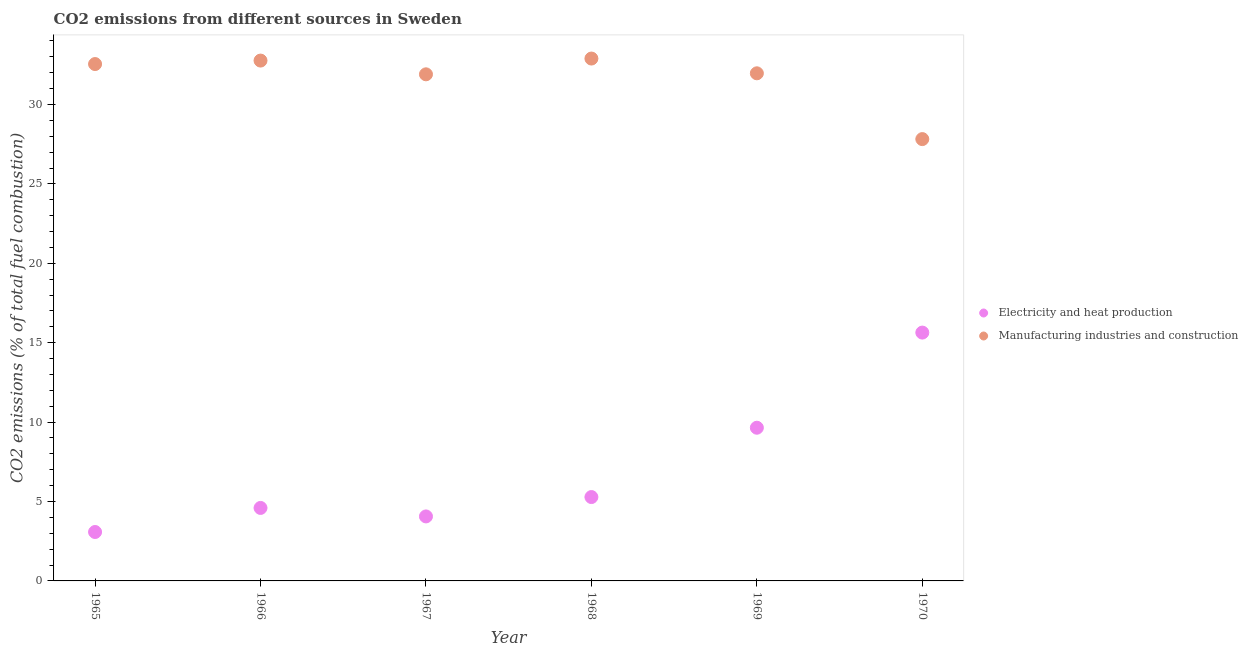Is the number of dotlines equal to the number of legend labels?
Offer a very short reply. Yes. What is the co2 emissions due to electricity and heat production in 1968?
Your answer should be compact. 5.28. Across all years, what is the maximum co2 emissions due to manufacturing industries?
Offer a very short reply. 32.89. Across all years, what is the minimum co2 emissions due to manufacturing industries?
Keep it short and to the point. 27.82. In which year was the co2 emissions due to electricity and heat production maximum?
Your response must be concise. 1970. In which year was the co2 emissions due to electricity and heat production minimum?
Provide a short and direct response. 1965. What is the total co2 emissions due to manufacturing industries in the graph?
Provide a short and direct response. 189.89. What is the difference between the co2 emissions due to manufacturing industries in 1965 and that in 1968?
Your answer should be very brief. -0.35. What is the difference between the co2 emissions due to manufacturing industries in 1967 and the co2 emissions due to electricity and heat production in 1970?
Offer a terse response. 16.26. What is the average co2 emissions due to electricity and heat production per year?
Keep it short and to the point. 7.05. In the year 1967, what is the difference between the co2 emissions due to manufacturing industries and co2 emissions due to electricity and heat production?
Your response must be concise. 27.84. In how many years, is the co2 emissions due to manufacturing industries greater than 22 %?
Keep it short and to the point. 6. What is the ratio of the co2 emissions due to electricity and heat production in 1967 to that in 1968?
Give a very brief answer. 0.77. Is the difference between the co2 emissions due to electricity and heat production in 1965 and 1966 greater than the difference between the co2 emissions due to manufacturing industries in 1965 and 1966?
Your response must be concise. No. What is the difference between the highest and the second highest co2 emissions due to manufacturing industries?
Offer a terse response. 0.13. What is the difference between the highest and the lowest co2 emissions due to manufacturing industries?
Offer a very short reply. 5.07. In how many years, is the co2 emissions due to electricity and heat production greater than the average co2 emissions due to electricity and heat production taken over all years?
Keep it short and to the point. 2. Is the co2 emissions due to electricity and heat production strictly greater than the co2 emissions due to manufacturing industries over the years?
Make the answer very short. No. Is the co2 emissions due to electricity and heat production strictly less than the co2 emissions due to manufacturing industries over the years?
Give a very brief answer. Yes. How many dotlines are there?
Offer a very short reply. 2. How many years are there in the graph?
Give a very brief answer. 6. Does the graph contain grids?
Provide a succinct answer. No. Where does the legend appear in the graph?
Provide a succinct answer. Center right. What is the title of the graph?
Ensure brevity in your answer.  CO2 emissions from different sources in Sweden. Does "Private credit bureau" appear as one of the legend labels in the graph?
Your answer should be compact. No. What is the label or title of the X-axis?
Offer a very short reply. Year. What is the label or title of the Y-axis?
Your answer should be very brief. CO2 emissions (% of total fuel combustion). What is the CO2 emissions (% of total fuel combustion) in Electricity and heat production in 1965?
Ensure brevity in your answer.  3.08. What is the CO2 emissions (% of total fuel combustion) of Manufacturing industries and construction in 1965?
Provide a short and direct response. 32.55. What is the CO2 emissions (% of total fuel combustion) in Electricity and heat production in 1966?
Your response must be concise. 4.6. What is the CO2 emissions (% of total fuel combustion) in Manufacturing industries and construction in 1966?
Offer a terse response. 32.77. What is the CO2 emissions (% of total fuel combustion) in Electricity and heat production in 1967?
Provide a short and direct response. 4.06. What is the CO2 emissions (% of total fuel combustion) of Manufacturing industries and construction in 1967?
Ensure brevity in your answer.  31.9. What is the CO2 emissions (% of total fuel combustion) in Electricity and heat production in 1968?
Make the answer very short. 5.28. What is the CO2 emissions (% of total fuel combustion) of Manufacturing industries and construction in 1968?
Offer a very short reply. 32.89. What is the CO2 emissions (% of total fuel combustion) in Electricity and heat production in 1969?
Give a very brief answer. 9.65. What is the CO2 emissions (% of total fuel combustion) of Manufacturing industries and construction in 1969?
Ensure brevity in your answer.  31.96. What is the CO2 emissions (% of total fuel combustion) in Electricity and heat production in 1970?
Ensure brevity in your answer.  15.64. What is the CO2 emissions (% of total fuel combustion) in Manufacturing industries and construction in 1970?
Your response must be concise. 27.82. Across all years, what is the maximum CO2 emissions (% of total fuel combustion) in Electricity and heat production?
Your answer should be compact. 15.64. Across all years, what is the maximum CO2 emissions (% of total fuel combustion) of Manufacturing industries and construction?
Offer a very short reply. 32.89. Across all years, what is the minimum CO2 emissions (% of total fuel combustion) of Electricity and heat production?
Give a very brief answer. 3.08. Across all years, what is the minimum CO2 emissions (% of total fuel combustion) in Manufacturing industries and construction?
Provide a short and direct response. 27.82. What is the total CO2 emissions (% of total fuel combustion) in Electricity and heat production in the graph?
Provide a succinct answer. 42.3. What is the total CO2 emissions (% of total fuel combustion) of Manufacturing industries and construction in the graph?
Provide a short and direct response. 189.89. What is the difference between the CO2 emissions (% of total fuel combustion) in Electricity and heat production in 1965 and that in 1966?
Provide a short and direct response. -1.52. What is the difference between the CO2 emissions (% of total fuel combustion) of Manufacturing industries and construction in 1965 and that in 1966?
Your response must be concise. -0.22. What is the difference between the CO2 emissions (% of total fuel combustion) in Electricity and heat production in 1965 and that in 1967?
Your response must be concise. -0.98. What is the difference between the CO2 emissions (% of total fuel combustion) of Manufacturing industries and construction in 1965 and that in 1967?
Provide a succinct answer. 0.65. What is the difference between the CO2 emissions (% of total fuel combustion) of Electricity and heat production in 1965 and that in 1968?
Provide a succinct answer. -2.2. What is the difference between the CO2 emissions (% of total fuel combustion) of Manufacturing industries and construction in 1965 and that in 1968?
Keep it short and to the point. -0.35. What is the difference between the CO2 emissions (% of total fuel combustion) in Electricity and heat production in 1965 and that in 1969?
Ensure brevity in your answer.  -6.57. What is the difference between the CO2 emissions (% of total fuel combustion) in Manufacturing industries and construction in 1965 and that in 1969?
Your response must be concise. 0.58. What is the difference between the CO2 emissions (% of total fuel combustion) of Electricity and heat production in 1965 and that in 1970?
Provide a succinct answer. -12.56. What is the difference between the CO2 emissions (% of total fuel combustion) of Manufacturing industries and construction in 1965 and that in 1970?
Offer a terse response. 4.73. What is the difference between the CO2 emissions (% of total fuel combustion) in Electricity and heat production in 1966 and that in 1967?
Your answer should be very brief. 0.53. What is the difference between the CO2 emissions (% of total fuel combustion) of Manufacturing industries and construction in 1966 and that in 1967?
Ensure brevity in your answer.  0.87. What is the difference between the CO2 emissions (% of total fuel combustion) in Electricity and heat production in 1966 and that in 1968?
Ensure brevity in your answer.  -0.69. What is the difference between the CO2 emissions (% of total fuel combustion) of Manufacturing industries and construction in 1966 and that in 1968?
Your response must be concise. -0.13. What is the difference between the CO2 emissions (% of total fuel combustion) of Electricity and heat production in 1966 and that in 1969?
Your answer should be very brief. -5.05. What is the difference between the CO2 emissions (% of total fuel combustion) in Manufacturing industries and construction in 1966 and that in 1969?
Keep it short and to the point. 0.8. What is the difference between the CO2 emissions (% of total fuel combustion) in Electricity and heat production in 1966 and that in 1970?
Provide a succinct answer. -11.04. What is the difference between the CO2 emissions (% of total fuel combustion) of Manufacturing industries and construction in 1966 and that in 1970?
Your response must be concise. 4.94. What is the difference between the CO2 emissions (% of total fuel combustion) in Electricity and heat production in 1967 and that in 1968?
Offer a terse response. -1.22. What is the difference between the CO2 emissions (% of total fuel combustion) of Manufacturing industries and construction in 1967 and that in 1968?
Your answer should be compact. -0.99. What is the difference between the CO2 emissions (% of total fuel combustion) in Electricity and heat production in 1967 and that in 1969?
Offer a terse response. -5.59. What is the difference between the CO2 emissions (% of total fuel combustion) in Manufacturing industries and construction in 1967 and that in 1969?
Your answer should be very brief. -0.06. What is the difference between the CO2 emissions (% of total fuel combustion) in Electricity and heat production in 1967 and that in 1970?
Your answer should be very brief. -11.58. What is the difference between the CO2 emissions (% of total fuel combustion) of Manufacturing industries and construction in 1967 and that in 1970?
Ensure brevity in your answer.  4.08. What is the difference between the CO2 emissions (% of total fuel combustion) in Electricity and heat production in 1968 and that in 1969?
Your response must be concise. -4.37. What is the difference between the CO2 emissions (% of total fuel combustion) in Manufacturing industries and construction in 1968 and that in 1969?
Your answer should be very brief. 0.93. What is the difference between the CO2 emissions (% of total fuel combustion) in Electricity and heat production in 1968 and that in 1970?
Keep it short and to the point. -10.36. What is the difference between the CO2 emissions (% of total fuel combustion) in Manufacturing industries and construction in 1968 and that in 1970?
Make the answer very short. 5.07. What is the difference between the CO2 emissions (% of total fuel combustion) in Electricity and heat production in 1969 and that in 1970?
Provide a short and direct response. -5.99. What is the difference between the CO2 emissions (% of total fuel combustion) in Manufacturing industries and construction in 1969 and that in 1970?
Keep it short and to the point. 4.14. What is the difference between the CO2 emissions (% of total fuel combustion) in Electricity and heat production in 1965 and the CO2 emissions (% of total fuel combustion) in Manufacturing industries and construction in 1966?
Provide a short and direct response. -29.68. What is the difference between the CO2 emissions (% of total fuel combustion) of Electricity and heat production in 1965 and the CO2 emissions (% of total fuel combustion) of Manufacturing industries and construction in 1967?
Keep it short and to the point. -28.82. What is the difference between the CO2 emissions (% of total fuel combustion) of Electricity and heat production in 1965 and the CO2 emissions (% of total fuel combustion) of Manufacturing industries and construction in 1968?
Your answer should be very brief. -29.81. What is the difference between the CO2 emissions (% of total fuel combustion) in Electricity and heat production in 1965 and the CO2 emissions (% of total fuel combustion) in Manufacturing industries and construction in 1969?
Give a very brief answer. -28.88. What is the difference between the CO2 emissions (% of total fuel combustion) of Electricity and heat production in 1965 and the CO2 emissions (% of total fuel combustion) of Manufacturing industries and construction in 1970?
Your response must be concise. -24.74. What is the difference between the CO2 emissions (% of total fuel combustion) of Electricity and heat production in 1966 and the CO2 emissions (% of total fuel combustion) of Manufacturing industries and construction in 1967?
Your answer should be compact. -27.3. What is the difference between the CO2 emissions (% of total fuel combustion) of Electricity and heat production in 1966 and the CO2 emissions (% of total fuel combustion) of Manufacturing industries and construction in 1968?
Ensure brevity in your answer.  -28.3. What is the difference between the CO2 emissions (% of total fuel combustion) of Electricity and heat production in 1966 and the CO2 emissions (% of total fuel combustion) of Manufacturing industries and construction in 1969?
Offer a very short reply. -27.37. What is the difference between the CO2 emissions (% of total fuel combustion) of Electricity and heat production in 1966 and the CO2 emissions (% of total fuel combustion) of Manufacturing industries and construction in 1970?
Your answer should be compact. -23.23. What is the difference between the CO2 emissions (% of total fuel combustion) in Electricity and heat production in 1967 and the CO2 emissions (% of total fuel combustion) in Manufacturing industries and construction in 1968?
Give a very brief answer. -28.83. What is the difference between the CO2 emissions (% of total fuel combustion) of Electricity and heat production in 1967 and the CO2 emissions (% of total fuel combustion) of Manufacturing industries and construction in 1969?
Your response must be concise. -27.9. What is the difference between the CO2 emissions (% of total fuel combustion) in Electricity and heat production in 1967 and the CO2 emissions (% of total fuel combustion) in Manufacturing industries and construction in 1970?
Provide a short and direct response. -23.76. What is the difference between the CO2 emissions (% of total fuel combustion) in Electricity and heat production in 1968 and the CO2 emissions (% of total fuel combustion) in Manufacturing industries and construction in 1969?
Make the answer very short. -26.68. What is the difference between the CO2 emissions (% of total fuel combustion) in Electricity and heat production in 1968 and the CO2 emissions (% of total fuel combustion) in Manufacturing industries and construction in 1970?
Ensure brevity in your answer.  -22.54. What is the difference between the CO2 emissions (% of total fuel combustion) of Electricity and heat production in 1969 and the CO2 emissions (% of total fuel combustion) of Manufacturing industries and construction in 1970?
Provide a succinct answer. -18.17. What is the average CO2 emissions (% of total fuel combustion) in Electricity and heat production per year?
Make the answer very short. 7.05. What is the average CO2 emissions (% of total fuel combustion) in Manufacturing industries and construction per year?
Give a very brief answer. 31.65. In the year 1965, what is the difference between the CO2 emissions (% of total fuel combustion) of Electricity and heat production and CO2 emissions (% of total fuel combustion) of Manufacturing industries and construction?
Ensure brevity in your answer.  -29.47. In the year 1966, what is the difference between the CO2 emissions (% of total fuel combustion) in Electricity and heat production and CO2 emissions (% of total fuel combustion) in Manufacturing industries and construction?
Offer a very short reply. -28.17. In the year 1967, what is the difference between the CO2 emissions (% of total fuel combustion) in Electricity and heat production and CO2 emissions (% of total fuel combustion) in Manufacturing industries and construction?
Give a very brief answer. -27.84. In the year 1968, what is the difference between the CO2 emissions (% of total fuel combustion) of Electricity and heat production and CO2 emissions (% of total fuel combustion) of Manufacturing industries and construction?
Offer a terse response. -27.61. In the year 1969, what is the difference between the CO2 emissions (% of total fuel combustion) in Electricity and heat production and CO2 emissions (% of total fuel combustion) in Manufacturing industries and construction?
Offer a terse response. -22.32. In the year 1970, what is the difference between the CO2 emissions (% of total fuel combustion) of Electricity and heat production and CO2 emissions (% of total fuel combustion) of Manufacturing industries and construction?
Ensure brevity in your answer.  -12.18. What is the ratio of the CO2 emissions (% of total fuel combustion) in Electricity and heat production in 1965 to that in 1966?
Keep it short and to the point. 0.67. What is the ratio of the CO2 emissions (% of total fuel combustion) in Manufacturing industries and construction in 1965 to that in 1966?
Ensure brevity in your answer.  0.99. What is the ratio of the CO2 emissions (% of total fuel combustion) in Electricity and heat production in 1965 to that in 1967?
Make the answer very short. 0.76. What is the ratio of the CO2 emissions (% of total fuel combustion) of Manufacturing industries and construction in 1965 to that in 1967?
Give a very brief answer. 1.02. What is the ratio of the CO2 emissions (% of total fuel combustion) in Electricity and heat production in 1965 to that in 1968?
Your answer should be very brief. 0.58. What is the ratio of the CO2 emissions (% of total fuel combustion) in Manufacturing industries and construction in 1965 to that in 1968?
Make the answer very short. 0.99. What is the ratio of the CO2 emissions (% of total fuel combustion) in Electricity and heat production in 1965 to that in 1969?
Provide a succinct answer. 0.32. What is the ratio of the CO2 emissions (% of total fuel combustion) in Manufacturing industries and construction in 1965 to that in 1969?
Your answer should be very brief. 1.02. What is the ratio of the CO2 emissions (% of total fuel combustion) of Electricity and heat production in 1965 to that in 1970?
Ensure brevity in your answer.  0.2. What is the ratio of the CO2 emissions (% of total fuel combustion) of Manufacturing industries and construction in 1965 to that in 1970?
Keep it short and to the point. 1.17. What is the ratio of the CO2 emissions (% of total fuel combustion) in Electricity and heat production in 1966 to that in 1967?
Offer a very short reply. 1.13. What is the ratio of the CO2 emissions (% of total fuel combustion) in Manufacturing industries and construction in 1966 to that in 1967?
Give a very brief answer. 1.03. What is the ratio of the CO2 emissions (% of total fuel combustion) of Electricity and heat production in 1966 to that in 1968?
Ensure brevity in your answer.  0.87. What is the ratio of the CO2 emissions (% of total fuel combustion) in Manufacturing industries and construction in 1966 to that in 1968?
Your answer should be compact. 1. What is the ratio of the CO2 emissions (% of total fuel combustion) of Electricity and heat production in 1966 to that in 1969?
Your response must be concise. 0.48. What is the ratio of the CO2 emissions (% of total fuel combustion) of Manufacturing industries and construction in 1966 to that in 1969?
Keep it short and to the point. 1.03. What is the ratio of the CO2 emissions (% of total fuel combustion) in Electricity and heat production in 1966 to that in 1970?
Give a very brief answer. 0.29. What is the ratio of the CO2 emissions (% of total fuel combustion) of Manufacturing industries and construction in 1966 to that in 1970?
Your response must be concise. 1.18. What is the ratio of the CO2 emissions (% of total fuel combustion) of Electricity and heat production in 1967 to that in 1968?
Your answer should be compact. 0.77. What is the ratio of the CO2 emissions (% of total fuel combustion) of Manufacturing industries and construction in 1967 to that in 1968?
Ensure brevity in your answer.  0.97. What is the ratio of the CO2 emissions (% of total fuel combustion) of Electricity and heat production in 1967 to that in 1969?
Make the answer very short. 0.42. What is the ratio of the CO2 emissions (% of total fuel combustion) in Electricity and heat production in 1967 to that in 1970?
Your answer should be compact. 0.26. What is the ratio of the CO2 emissions (% of total fuel combustion) of Manufacturing industries and construction in 1967 to that in 1970?
Your answer should be compact. 1.15. What is the ratio of the CO2 emissions (% of total fuel combustion) in Electricity and heat production in 1968 to that in 1969?
Provide a succinct answer. 0.55. What is the ratio of the CO2 emissions (% of total fuel combustion) of Manufacturing industries and construction in 1968 to that in 1969?
Your answer should be compact. 1.03. What is the ratio of the CO2 emissions (% of total fuel combustion) of Electricity and heat production in 1968 to that in 1970?
Keep it short and to the point. 0.34. What is the ratio of the CO2 emissions (% of total fuel combustion) in Manufacturing industries and construction in 1968 to that in 1970?
Your answer should be compact. 1.18. What is the ratio of the CO2 emissions (% of total fuel combustion) in Electricity and heat production in 1969 to that in 1970?
Provide a short and direct response. 0.62. What is the ratio of the CO2 emissions (% of total fuel combustion) of Manufacturing industries and construction in 1969 to that in 1970?
Make the answer very short. 1.15. What is the difference between the highest and the second highest CO2 emissions (% of total fuel combustion) in Electricity and heat production?
Offer a terse response. 5.99. What is the difference between the highest and the second highest CO2 emissions (% of total fuel combustion) in Manufacturing industries and construction?
Make the answer very short. 0.13. What is the difference between the highest and the lowest CO2 emissions (% of total fuel combustion) of Electricity and heat production?
Your answer should be compact. 12.56. What is the difference between the highest and the lowest CO2 emissions (% of total fuel combustion) of Manufacturing industries and construction?
Your answer should be very brief. 5.07. 